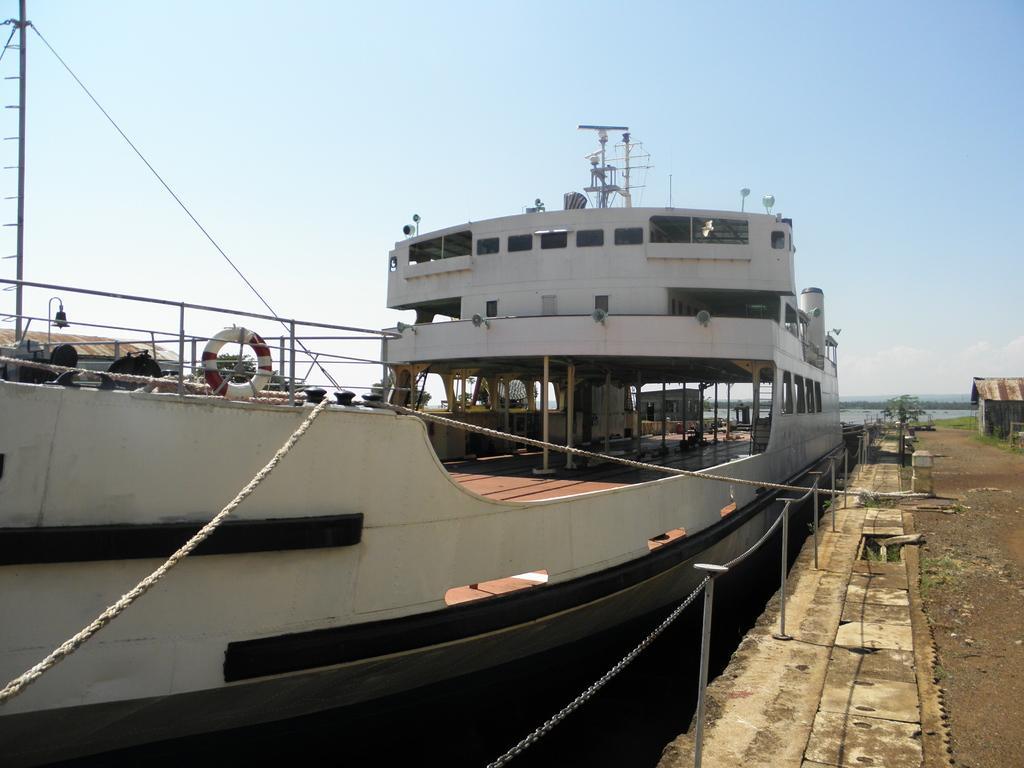Please provide a concise description of this image. In this image we can see ship, ropes, grass and in the background we can see the sky. 